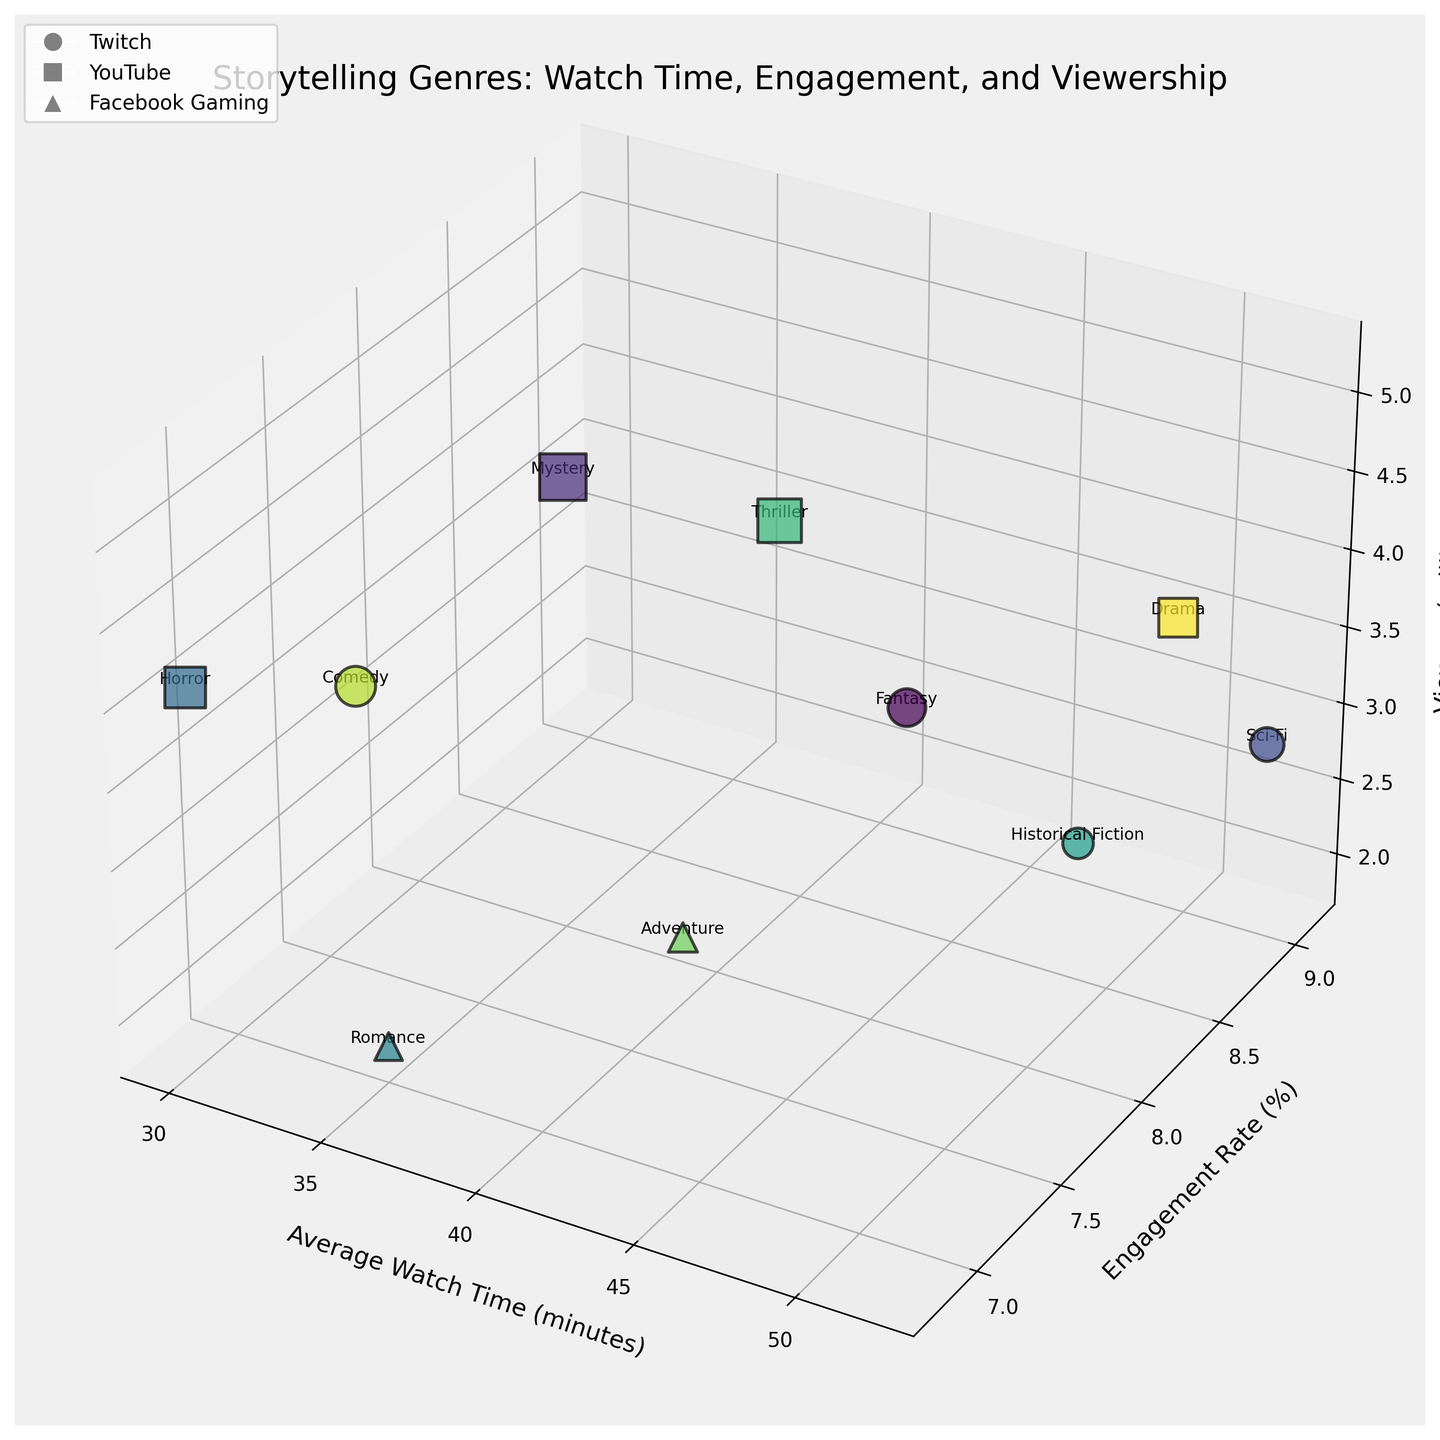what is the title of the plot? The title of the plot is typically found at the top of the figure. It serves to give a brief summary or description of what the plot represents. The title here is "Storytelling Genres: Watch Time, Engagement, and Viewership".
Answer: Storytelling Genres: Watch Time, Engagement, and Viewership How many data points represent genres from Twitch? To find this, we look at the markers specific to Twitch, which are circle-shaped. Counting these markers determines the number of data points from Twitch.
Answer: 5 Which genre on YouTube has the highest engagement rate? First, identify all the square markers representing YouTube. Then, compare the engagement rates by looking at the y-axis values. The genre with the highest y-coordinate among YouTube genres is Drama with an engagement rate of 8.9%.
Answer: Drama Is the average watch time for Sci-Fi greater than that for Adventure? Identify the Sci-Fi and Adventure data points. Then, compare their x-axis values (Average Watch Time). Sci-Fi has an average watch time of 52 minutes, while Adventure has 40 minutes. So, Sci-Fi has a greater average watch time.
Answer: Yes Which platform has the highest number of viewers for any genre? Look for the marker with the largest size (representing viewers) and note its corresponding platform. The genre Mystery on YouTube has the largest size, indicating the highest number of viewers at 5.2 million.
Answer: YouTube What is the difference in average watch time between Fantasy and Comedy genres on Twitch? Identify the Fantasy and Comedy data points on Twitch and note their x-axis values. Fantasy has 45 minutes, and Comedy has 33 minutes. The difference is 45 - 33 = 12 minutes.
Answer: 12 minutes Which genre has the lowest engagement rate and which platform is it on? Examine all data points and compare their y-axis values. The lowest engagement rate is 6.8%, belonging to the Horror genre on YouTube.
Answer: Horror on YouTube Is there a positive correlation between average watch time and engagement rate across all genres? To determine this, observe the general trend of the data points in their 3D space between the x-axis (Average Watch Time) and y-axis (Engagement Rate). If data points rise together, there is a positive correlation. The plot shows that genres with higher watch times also generally have higher engagement rates.
Answer: Yes Is the number of viewers for Romance on Facebook Gaming higher or lower than the number of viewers for Adventure on Facebook Gaming? Identify the Romance and Adventure markers on Facebook Gaming, then compare their bubble sizes which represent the number of viewers. Romance has 1.9 million viewers, while Adventure has 2.1 million viewers. Romance has a lower number of viewers.
Answer: Lower Which genre on Twitch has the highest average watch time? Look for the circle markers representing Twitch and compare their x-axis values. Sci-Fi has the highest average watch time of 52 minutes among genres on Twitch.
Answer: Sci-Fi 